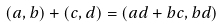<formula> <loc_0><loc_0><loc_500><loc_500>( a , b ) + ( c , d ) = ( a d + b c , b d )</formula> 